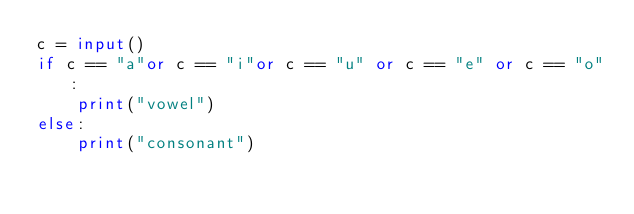Convert code to text. <code><loc_0><loc_0><loc_500><loc_500><_Python_>c = input()
if c == "a"or c == "i"or c == "u" or c == "e" or c == "o":
    print("vowel")
else:
    print("consonant")
</code> 